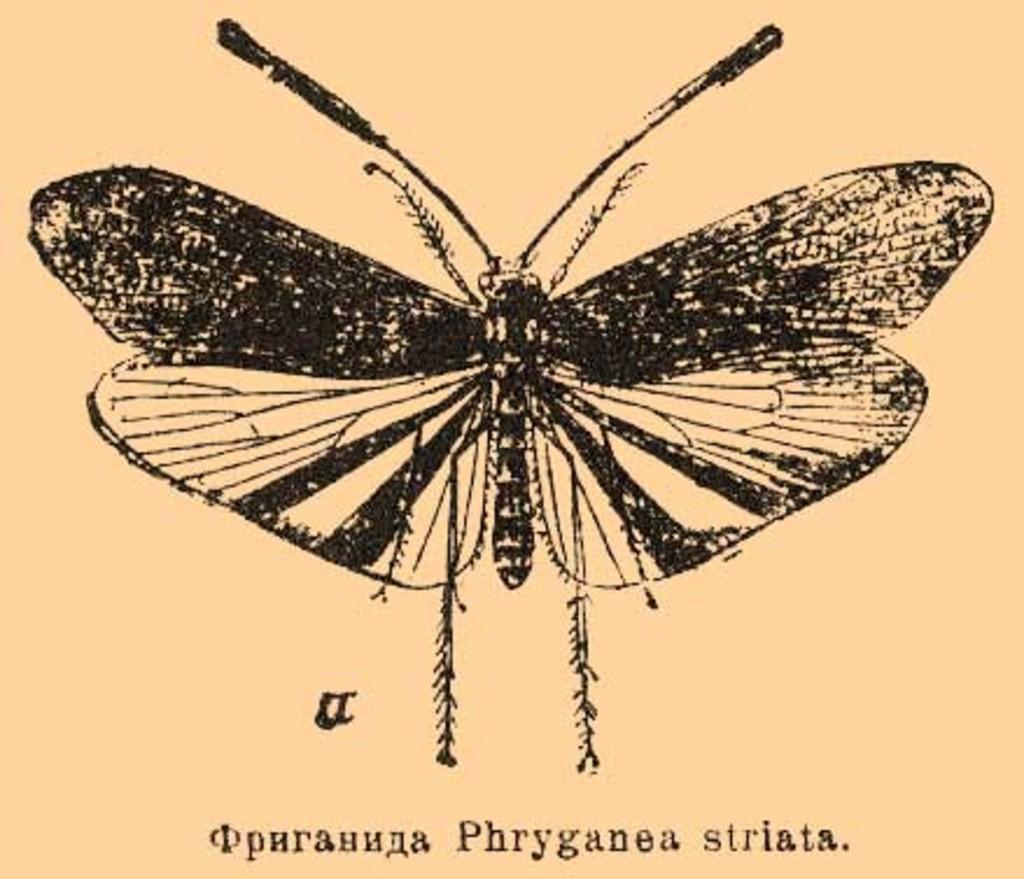Can you describe this image briefly? In this image there is a butterfly and at the bottom there is some text written on it. 